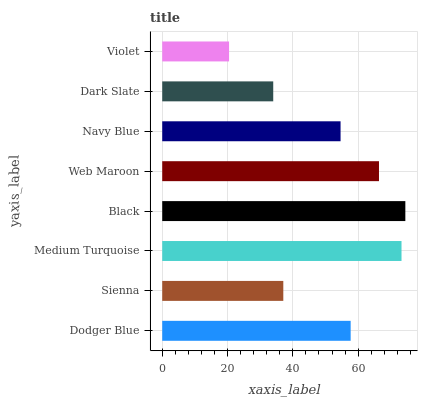Is Violet the minimum?
Answer yes or no. Yes. Is Black the maximum?
Answer yes or no. Yes. Is Sienna the minimum?
Answer yes or no. No. Is Sienna the maximum?
Answer yes or no. No. Is Dodger Blue greater than Sienna?
Answer yes or no. Yes. Is Sienna less than Dodger Blue?
Answer yes or no. Yes. Is Sienna greater than Dodger Blue?
Answer yes or no. No. Is Dodger Blue less than Sienna?
Answer yes or no. No. Is Dodger Blue the high median?
Answer yes or no. Yes. Is Navy Blue the low median?
Answer yes or no. Yes. Is Sienna the high median?
Answer yes or no. No. Is Dark Slate the low median?
Answer yes or no. No. 